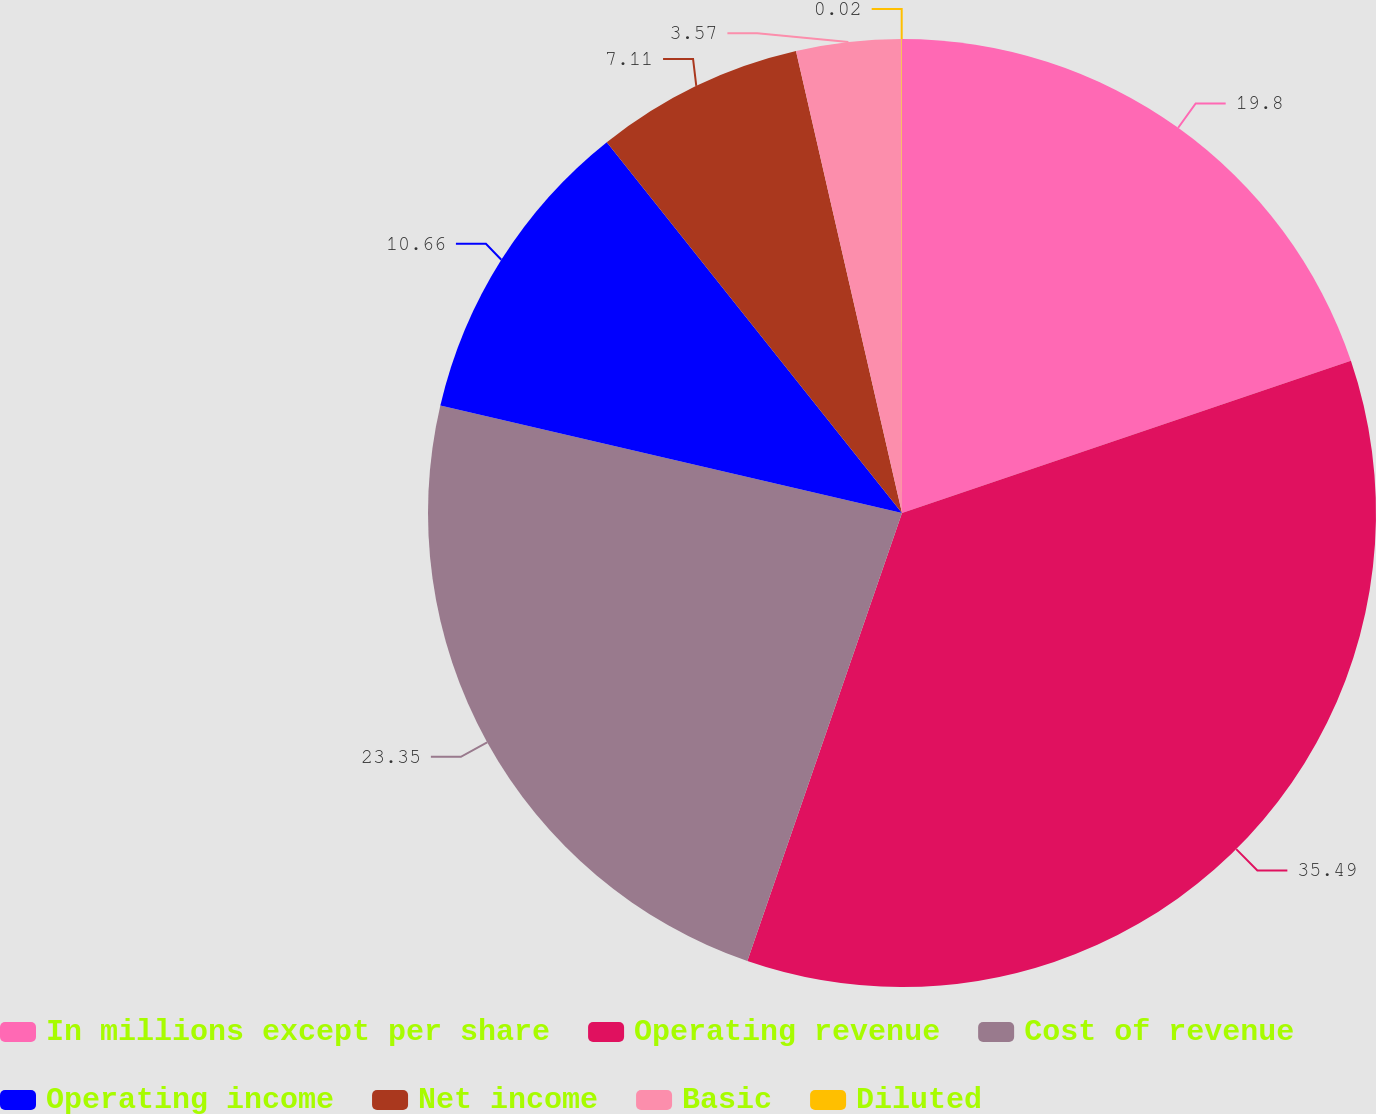Convert chart. <chart><loc_0><loc_0><loc_500><loc_500><pie_chart><fcel>In millions except per share<fcel>Operating revenue<fcel>Cost of revenue<fcel>Operating income<fcel>Net income<fcel>Basic<fcel>Diluted<nl><fcel>19.8%<fcel>35.49%<fcel>23.35%<fcel>10.66%<fcel>7.11%<fcel>3.57%<fcel>0.02%<nl></chart> 